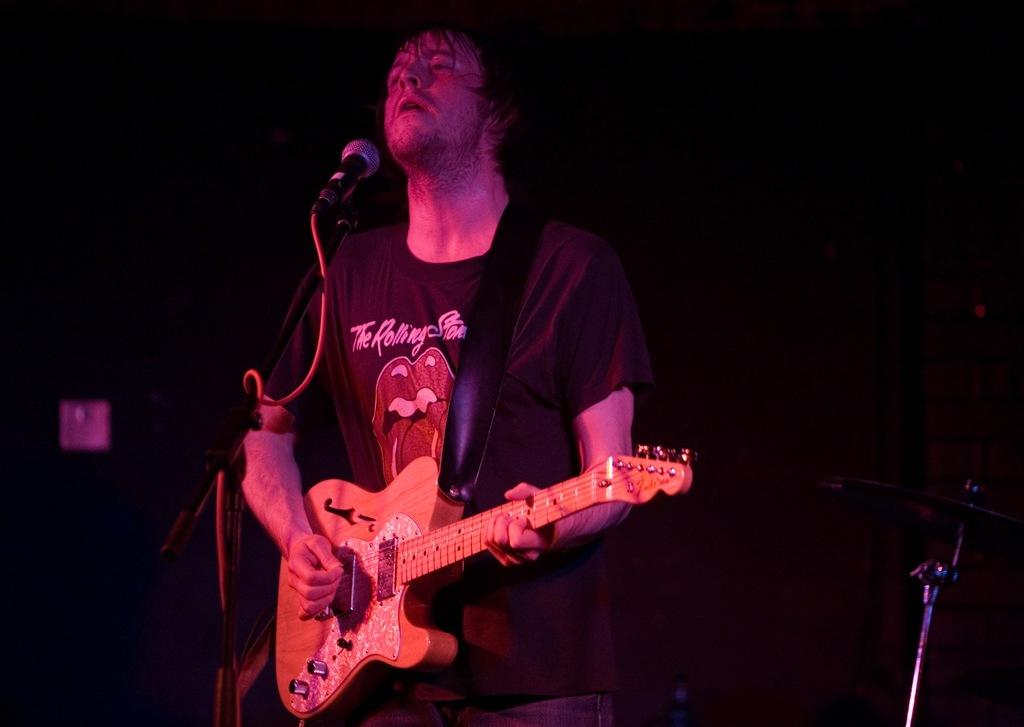Who is the main subject in the image? There is a person in the image. What is the person doing in the image? The person is standing in front of a mic and holding a guitar. What type of brass instrument can be seen in the image? There is no brass instrument present in the image; the person is holding a guitar. 